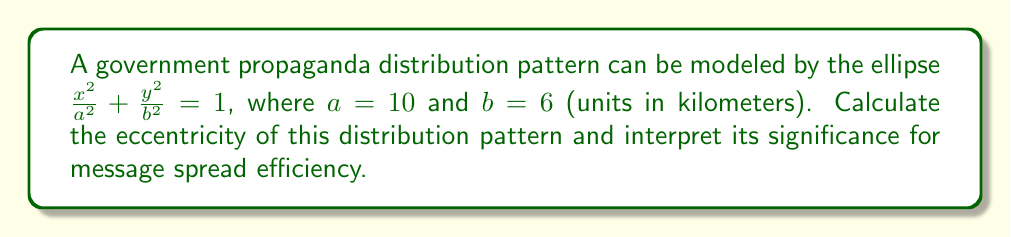Provide a solution to this math problem. To solve this problem, we need to follow these steps:

1) Recall the formula for eccentricity of an ellipse:

   $$e = \sqrt{1 - \frac{b^2}{a^2}}$$

   where $a$ is the length of the semi-major axis and $b$ is the length of the semi-minor axis.

2) We are given that $a = 10$ and $b = 6$. Let's substitute these values:

   $$e = \sqrt{1 - \frac{6^2}{10^2}}$$

3) Simplify inside the square root:

   $$e = \sqrt{1 - \frac{36}{100}} = \sqrt{1 - 0.36} = \sqrt{0.64}$$

4) Calculate the final value:

   $$e = 0.8$$

Interpretation:
The eccentricity of an ellipse ranges from 0 (a circle) to values approaching 1 (a very elongated ellipse). An eccentricity of 0.8 indicates a moderately elongated ellipse.

In the context of propaganda distribution, this suggests:
- The pattern of information spread is not uniform in all directions.
- There is a clear major axis along which the propaganda spreads more efficiently.
- This could represent a focused distribution strategy, perhaps targeting specific geographic or demographic corridors.
- The elongated shape might indicate a more efficient use of resources, concentrating efforts along a primary axis rather than spreading equally in all directions.
Answer: The eccentricity of the propaganda distribution pattern is 0.8, indicating a moderately elongated elliptical spread that suggests a focused and potentially more efficient distribution strategy along a primary axis. 